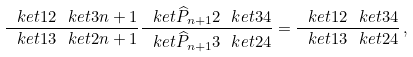Convert formula to latex. <formula><loc_0><loc_0><loc_500><loc_500>\frac { \ k e t { 1 } { 2 } \ k e t { 3 } { n + 1 } } { \ k e t { 1 } { 3 } \ k e t { 2 } { n + 1 } } \frac { \ k e t { \widehat { P } _ { n + 1 } } { 2 } \ k e t { 3 } { 4 } } { \ k e t { \widehat { P } _ { n + 1 } } { 3 } \ k e t { 2 } { 4 } } = \frac { \ k e t { 1 } { 2 } \ k e t { 3 } { 4 } } { \ k e t { 1 } { 3 } \ k e t { 2 } { 4 } } \, ,</formula> 